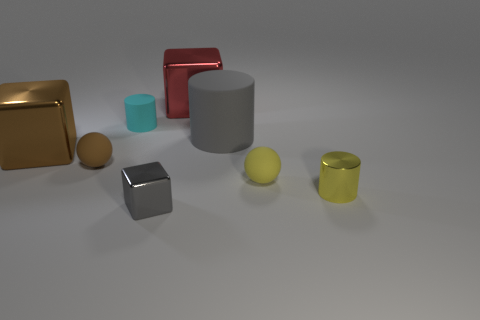What can you infer about the lighting in this scene? The scene is lit from above, as indicated by the soft shadows cast directly underneath each object. The light appears to be diffused, resulting in soft edges of the shadows with minimal contrast between the lit and shadowed areas, creating a calm and even atmosphere. 